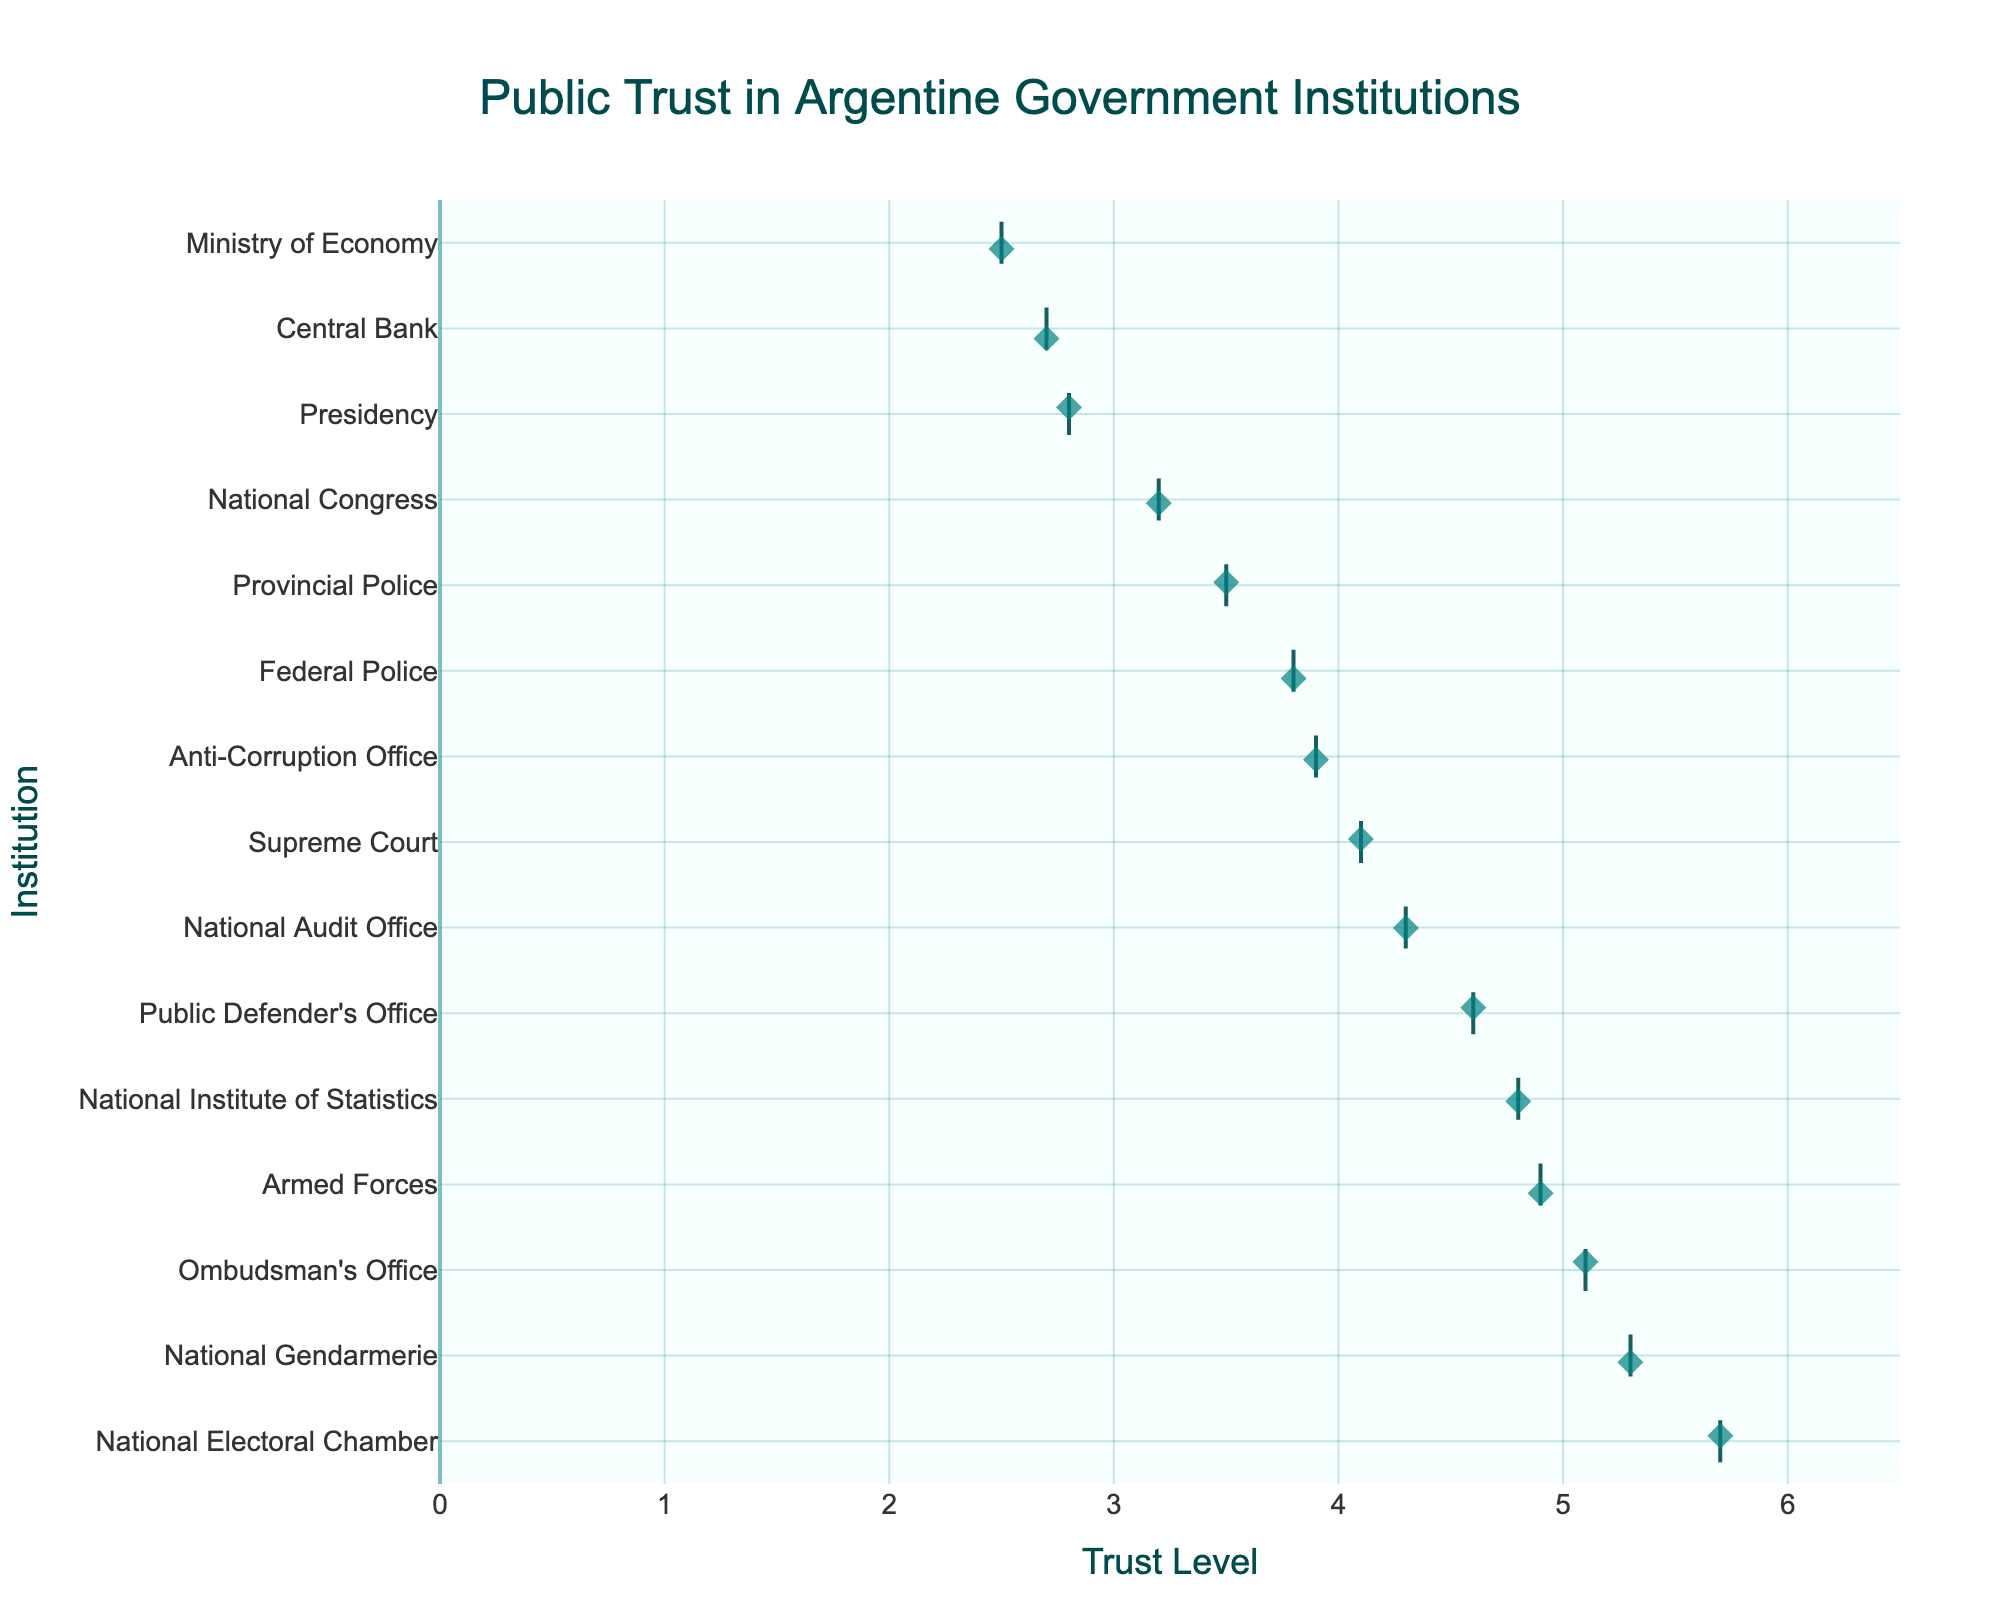What is the title of the plot? The title of the plot can be found at the top center. It describes what the plot is about.
Answer: Public Trust in Argentine Government Institutions What is the highest trust level recorded for any institution? The highest trust level is the maximum value on the horizontal axis. In the plot, the value close to 6 is the highest.
Answer: 5.7 What is the institution with the lowest trust level? The lowest trust level is identified by looking at the institutions on the y-axis and finding the smallest value on the x-axis.
Answer: Ministry of Economy How many institutions have a trust level above 5? Count the number of institutions whose trust level bars extend beyond the 5 mark on the x-axis.
Answer: 3 Which institution's trust level is closest to the median of all institutions? To find the median, list all trust levels in ascending order and locate the middle value. The institution with this trust level is the answer.
Answer: Public Defender's Office What is the difference in trust levels between the Armed Forces and the Provincial Police? Locate the Armed Forces and Provincial Police on the y-axis, find their corresponding trust levels on the x-axis, and subtract the latter from the former.
Answer: 1.4 Which institutions have a trust level equal to or greater than 4 but less than 5? Identify institutions with trust levels clearly falling within the range 4 to 5 on the x-axis.
Answer: Supreme Court, Federal Police, Public Defender's Office, National Audit Office, National Institute of Statistics Is the trust level in the National Congress higher or lower than that in the Central Bank? Compare the locations of National Congress and Central Bank on the y-axis and their corresponding trust levels on the x-axis.
Answer: Higher What color is used for the markers on the strip plot? The color can be identified by looking at any of the markers on the plot.
Answer: Teal Which two institutions have trust levels closest to each other? Find pairs of institutions on the y-axis with trust levels very close together on the x-axis.
Answer: National Audit Office and Anti-Corruption Office What is the range of trust levels across all institutions? Subtract the lowest trust level observed from the highest trust level.
Answer: 3.2 